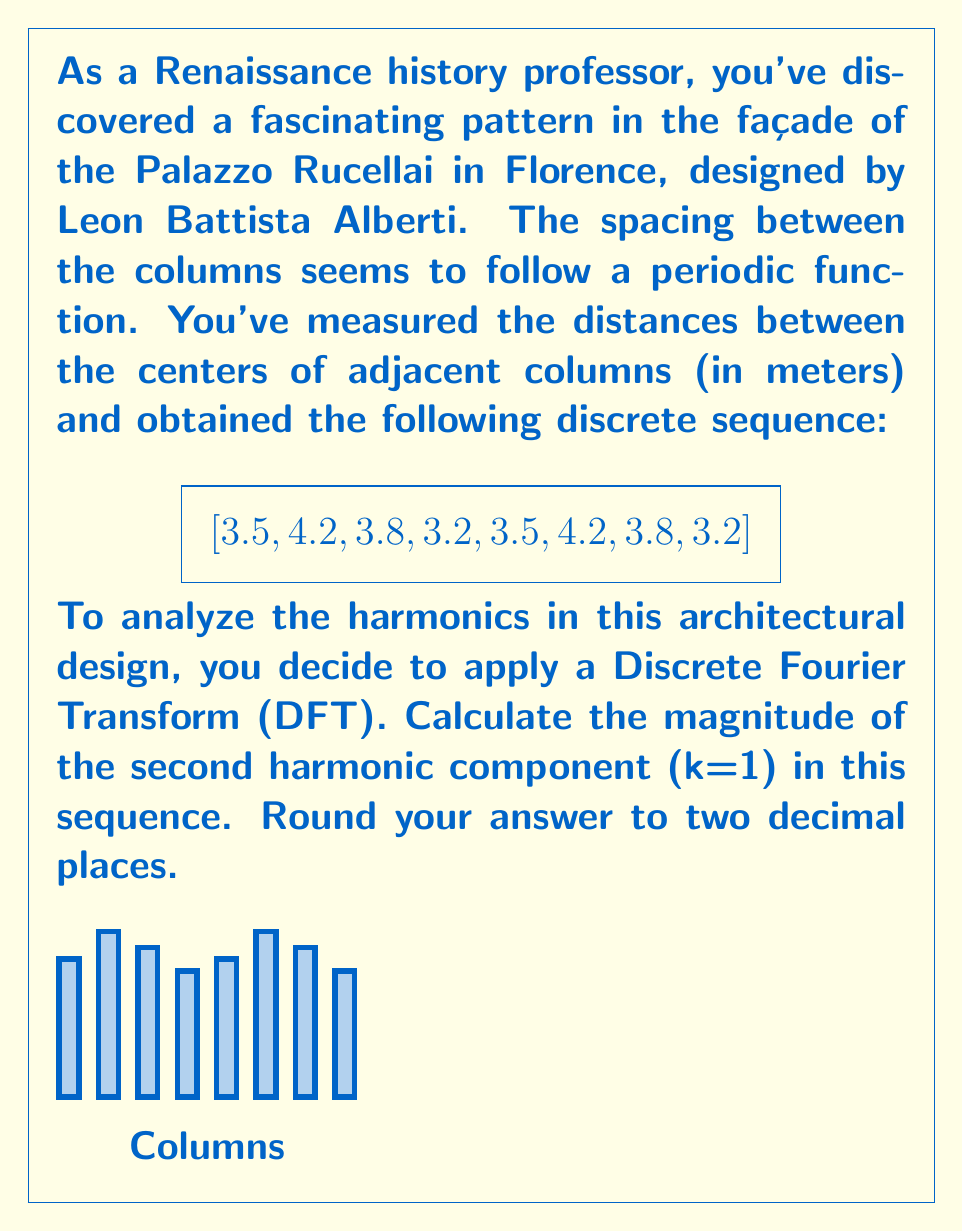Provide a solution to this math problem. Let's approach this step-by-step:

1) The Discrete Fourier Transform (DFT) of a sequence x[n] of length N is given by:

   $$X[k] = \sum_{n=0}^{N-1} x[n] e^{-j2\pi kn/N}$$

   where k = 0, 1, ..., N-1

2) In our case, N = 8 and we're interested in k = 1 (the second harmonic).

3) Let's expand the formula for k = 1:

   $$X[1] = \sum_{n=0}^{7} x[n] e^{-j2\pi n/8}$$

4) We can use Euler's formula to express this in terms of sine and cosine:

   $$X[1] = \sum_{n=0}^{7} x[n] (\cos(2\pi n/8) - j\sin(2\pi n/8))$$

5) Let's calculate this sum:

   $$\begin{align*}
   X[1] &= 3.5(1 - j0) + 4.2(\frac{\sqrt{2}}{2} - j\frac{\sqrt{2}}{2}) + 3.8(0 - j1) + 3.2(-\frac{\sqrt{2}}{2} - j\frac{\sqrt{2}}{2}) \\
   &+ 3.5(-1 - j0) + 4.2(-\frac{\sqrt{2}}{2} + j\frac{\sqrt{2}}{2}) + 3.8(0 + j1) + 3.2(\frac{\sqrt{2}}{2} + j\frac{\sqrt{2}}{2})
   \end{align*}$$

6) Simplifying:

   $$X[1] = (3.5 - 3.5) + (4.2 - 4.2)\frac{\sqrt{2}}{2} + (3.2 - 3.2)\frac{\sqrt{2}}{2} + j[(4.2 - 4.2)\frac{\sqrt{2}}{2} + (3.8 - 3.8) + (3.2 - 3.2)\frac{\sqrt{2}}{2}]$$

7) This simplifies to:

   $$X[1] = 0 + 0j = 0$$

8) The magnitude of a complex number $a + bj$ is given by $\sqrt{a^2 + b^2}$.

9) Therefore, the magnitude of X[1] is:

   $$|X[1]| = \sqrt{0^2 + 0^2} = 0$$

10) Rounding to two decimal places: 0.00
Answer: 0.00 